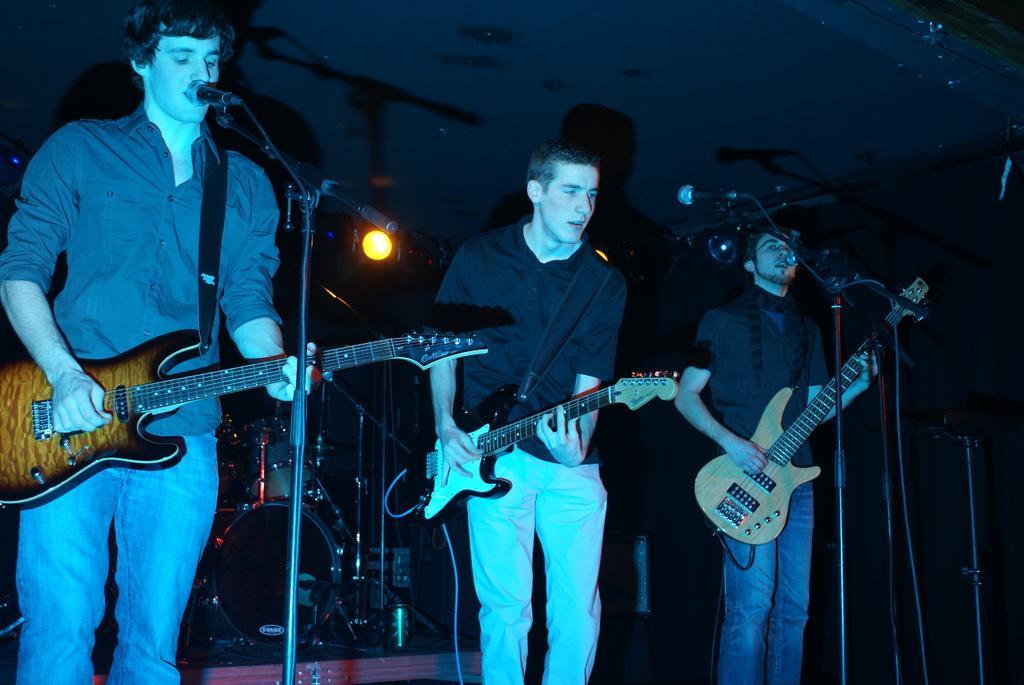Can you describe this image briefly? In this picture there are three men playing guitars. There are three mics in front of them. There is light behind them focusing. There is a drum set. 